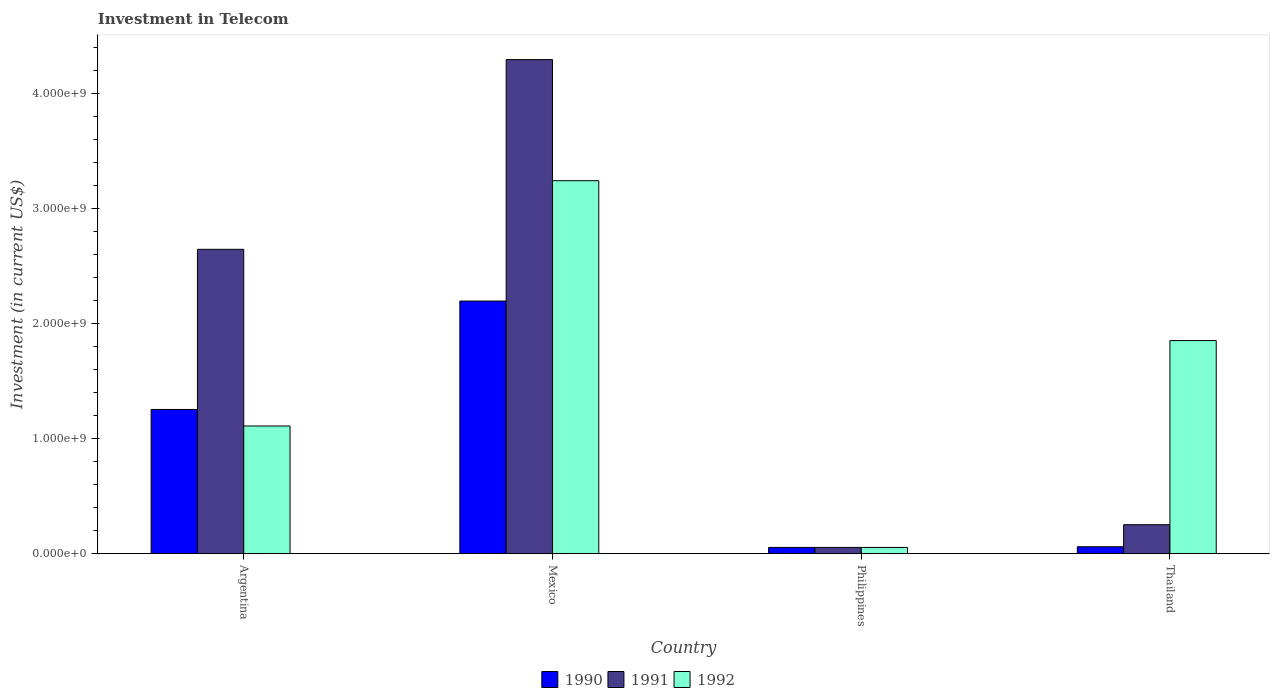How many different coloured bars are there?
Make the answer very short. 3. Are the number of bars per tick equal to the number of legend labels?
Offer a very short reply. Yes. How many bars are there on the 2nd tick from the left?
Offer a very short reply. 3. What is the label of the 1st group of bars from the left?
Your response must be concise. Argentina. What is the amount invested in telecom in 1992 in Thailand?
Make the answer very short. 1.85e+09. Across all countries, what is the maximum amount invested in telecom in 1991?
Your answer should be compact. 4.30e+09. Across all countries, what is the minimum amount invested in telecom in 1991?
Provide a short and direct response. 5.42e+07. In which country was the amount invested in telecom in 1991 minimum?
Your response must be concise. Philippines. What is the total amount invested in telecom in 1992 in the graph?
Make the answer very short. 6.26e+09. What is the difference between the amount invested in telecom in 1992 in Argentina and that in Thailand?
Provide a short and direct response. -7.43e+08. What is the difference between the amount invested in telecom in 1991 in Thailand and the amount invested in telecom in 1990 in Philippines?
Your response must be concise. 1.98e+08. What is the average amount invested in telecom in 1990 per country?
Keep it short and to the point. 8.92e+08. What is the ratio of the amount invested in telecom in 1992 in Argentina to that in Philippines?
Your answer should be very brief. 20.5. Is the amount invested in telecom in 1992 in Philippines less than that in Thailand?
Ensure brevity in your answer.  Yes. What is the difference between the highest and the second highest amount invested in telecom in 1990?
Provide a short and direct response. 2.14e+09. What is the difference between the highest and the lowest amount invested in telecom in 1991?
Your response must be concise. 4.24e+09. Is it the case that in every country, the sum of the amount invested in telecom in 1992 and amount invested in telecom in 1990 is greater than the amount invested in telecom in 1991?
Ensure brevity in your answer.  No. Are the values on the major ticks of Y-axis written in scientific E-notation?
Provide a succinct answer. Yes. Does the graph contain any zero values?
Provide a succinct answer. No. How are the legend labels stacked?
Ensure brevity in your answer.  Horizontal. What is the title of the graph?
Provide a succinct answer. Investment in Telecom. Does "1991" appear as one of the legend labels in the graph?
Ensure brevity in your answer.  Yes. What is the label or title of the X-axis?
Offer a terse response. Country. What is the label or title of the Y-axis?
Provide a succinct answer. Investment (in current US$). What is the Investment (in current US$) of 1990 in Argentina?
Your response must be concise. 1.25e+09. What is the Investment (in current US$) of 1991 in Argentina?
Offer a very short reply. 2.65e+09. What is the Investment (in current US$) in 1992 in Argentina?
Your response must be concise. 1.11e+09. What is the Investment (in current US$) of 1990 in Mexico?
Give a very brief answer. 2.20e+09. What is the Investment (in current US$) in 1991 in Mexico?
Keep it short and to the point. 4.30e+09. What is the Investment (in current US$) in 1992 in Mexico?
Keep it short and to the point. 3.24e+09. What is the Investment (in current US$) in 1990 in Philippines?
Make the answer very short. 5.42e+07. What is the Investment (in current US$) in 1991 in Philippines?
Offer a very short reply. 5.42e+07. What is the Investment (in current US$) of 1992 in Philippines?
Give a very brief answer. 5.42e+07. What is the Investment (in current US$) of 1990 in Thailand?
Your answer should be very brief. 6.00e+07. What is the Investment (in current US$) in 1991 in Thailand?
Offer a very short reply. 2.52e+08. What is the Investment (in current US$) of 1992 in Thailand?
Offer a terse response. 1.85e+09. Across all countries, what is the maximum Investment (in current US$) of 1990?
Provide a succinct answer. 2.20e+09. Across all countries, what is the maximum Investment (in current US$) in 1991?
Provide a short and direct response. 4.30e+09. Across all countries, what is the maximum Investment (in current US$) of 1992?
Provide a short and direct response. 3.24e+09. Across all countries, what is the minimum Investment (in current US$) in 1990?
Your response must be concise. 5.42e+07. Across all countries, what is the minimum Investment (in current US$) in 1991?
Make the answer very short. 5.42e+07. Across all countries, what is the minimum Investment (in current US$) in 1992?
Provide a short and direct response. 5.42e+07. What is the total Investment (in current US$) of 1990 in the graph?
Give a very brief answer. 3.57e+09. What is the total Investment (in current US$) of 1991 in the graph?
Provide a short and direct response. 7.25e+09. What is the total Investment (in current US$) in 1992 in the graph?
Your answer should be very brief. 6.26e+09. What is the difference between the Investment (in current US$) in 1990 in Argentina and that in Mexico?
Offer a terse response. -9.43e+08. What is the difference between the Investment (in current US$) in 1991 in Argentina and that in Mexico?
Offer a very short reply. -1.65e+09. What is the difference between the Investment (in current US$) in 1992 in Argentina and that in Mexico?
Offer a very short reply. -2.13e+09. What is the difference between the Investment (in current US$) of 1990 in Argentina and that in Philippines?
Give a very brief answer. 1.20e+09. What is the difference between the Investment (in current US$) of 1991 in Argentina and that in Philippines?
Your answer should be very brief. 2.59e+09. What is the difference between the Investment (in current US$) of 1992 in Argentina and that in Philippines?
Your answer should be very brief. 1.06e+09. What is the difference between the Investment (in current US$) of 1990 in Argentina and that in Thailand?
Offer a terse response. 1.19e+09. What is the difference between the Investment (in current US$) in 1991 in Argentina and that in Thailand?
Offer a terse response. 2.40e+09. What is the difference between the Investment (in current US$) of 1992 in Argentina and that in Thailand?
Your answer should be compact. -7.43e+08. What is the difference between the Investment (in current US$) in 1990 in Mexico and that in Philippines?
Your answer should be compact. 2.14e+09. What is the difference between the Investment (in current US$) in 1991 in Mexico and that in Philippines?
Your answer should be compact. 4.24e+09. What is the difference between the Investment (in current US$) of 1992 in Mexico and that in Philippines?
Ensure brevity in your answer.  3.19e+09. What is the difference between the Investment (in current US$) in 1990 in Mexico and that in Thailand?
Your answer should be very brief. 2.14e+09. What is the difference between the Investment (in current US$) in 1991 in Mexico and that in Thailand?
Offer a terse response. 4.05e+09. What is the difference between the Investment (in current US$) in 1992 in Mexico and that in Thailand?
Make the answer very short. 1.39e+09. What is the difference between the Investment (in current US$) in 1990 in Philippines and that in Thailand?
Keep it short and to the point. -5.80e+06. What is the difference between the Investment (in current US$) of 1991 in Philippines and that in Thailand?
Provide a succinct answer. -1.98e+08. What is the difference between the Investment (in current US$) of 1992 in Philippines and that in Thailand?
Give a very brief answer. -1.80e+09. What is the difference between the Investment (in current US$) of 1990 in Argentina and the Investment (in current US$) of 1991 in Mexico?
Keep it short and to the point. -3.04e+09. What is the difference between the Investment (in current US$) of 1990 in Argentina and the Investment (in current US$) of 1992 in Mexico?
Your response must be concise. -1.99e+09. What is the difference between the Investment (in current US$) of 1991 in Argentina and the Investment (in current US$) of 1992 in Mexico?
Give a very brief answer. -5.97e+08. What is the difference between the Investment (in current US$) in 1990 in Argentina and the Investment (in current US$) in 1991 in Philippines?
Your response must be concise. 1.20e+09. What is the difference between the Investment (in current US$) in 1990 in Argentina and the Investment (in current US$) in 1992 in Philippines?
Your answer should be compact. 1.20e+09. What is the difference between the Investment (in current US$) in 1991 in Argentina and the Investment (in current US$) in 1992 in Philippines?
Ensure brevity in your answer.  2.59e+09. What is the difference between the Investment (in current US$) in 1990 in Argentina and the Investment (in current US$) in 1991 in Thailand?
Make the answer very short. 1.00e+09. What is the difference between the Investment (in current US$) of 1990 in Argentina and the Investment (in current US$) of 1992 in Thailand?
Your response must be concise. -5.99e+08. What is the difference between the Investment (in current US$) in 1991 in Argentina and the Investment (in current US$) in 1992 in Thailand?
Provide a succinct answer. 7.94e+08. What is the difference between the Investment (in current US$) in 1990 in Mexico and the Investment (in current US$) in 1991 in Philippines?
Ensure brevity in your answer.  2.14e+09. What is the difference between the Investment (in current US$) of 1990 in Mexico and the Investment (in current US$) of 1992 in Philippines?
Your response must be concise. 2.14e+09. What is the difference between the Investment (in current US$) of 1991 in Mexico and the Investment (in current US$) of 1992 in Philippines?
Ensure brevity in your answer.  4.24e+09. What is the difference between the Investment (in current US$) in 1990 in Mexico and the Investment (in current US$) in 1991 in Thailand?
Offer a terse response. 1.95e+09. What is the difference between the Investment (in current US$) of 1990 in Mexico and the Investment (in current US$) of 1992 in Thailand?
Give a very brief answer. 3.44e+08. What is the difference between the Investment (in current US$) of 1991 in Mexico and the Investment (in current US$) of 1992 in Thailand?
Provide a succinct answer. 2.44e+09. What is the difference between the Investment (in current US$) in 1990 in Philippines and the Investment (in current US$) in 1991 in Thailand?
Your response must be concise. -1.98e+08. What is the difference between the Investment (in current US$) of 1990 in Philippines and the Investment (in current US$) of 1992 in Thailand?
Provide a succinct answer. -1.80e+09. What is the difference between the Investment (in current US$) of 1991 in Philippines and the Investment (in current US$) of 1992 in Thailand?
Provide a succinct answer. -1.80e+09. What is the average Investment (in current US$) of 1990 per country?
Keep it short and to the point. 8.92e+08. What is the average Investment (in current US$) of 1991 per country?
Offer a very short reply. 1.81e+09. What is the average Investment (in current US$) in 1992 per country?
Your answer should be very brief. 1.57e+09. What is the difference between the Investment (in current US$) of 1990 and Investment (in current US$) of 1991 in Argentina?
Provide a succinct answer. -1.39e+09. What is the difference between the Investment (in current US$) in 1990 and Investment (in current US$) in 1992 in Argentina?
Give a very brief answer. 1.44e+08. What is the difference between the Investment (in current US$) of 1991 and Investment (in current US$) of 1992 in Argentina?
Make the answer very short. 1.54e+09. What is the difference between the Investment (in current US$) in 1990 and Investment (in current US$) in 1991 in Mexico?
Keep it short and to the point. -2.10e+09. What is the difference between the Investment (in current US$) of 1990 and Investment (in current US$) of 1992 in Mexico?
Your response must be concise. -1.05e+09. What is the difference between the Investment (in current US$) in 1991 and Investment (in current US$) in 1992 in Mexico?
Your response must be concise. 1.05e+09. What is the difference between the Investment (in current US$) in 1990 and Investment (in current US$) in 1991 in Philippines?
Make the answer very short. 0. What is the difference between the Investment (in current US$) of 1990 and Investment (in current US$) of 1991 in Thailand?
Keep it short and to the point. -1.92e+08. What is the difference between the Investment (in current US$) in 1990 and Investment (in current US$) in 1992 in Thailand?
Your answer should be very brief. -1.79e+09. What is the difference between the Investment (in current US$) of 1991 and Investment (in current US$) of 1992 in Thailand?
Offer a very short reply. -1.60e+09. What is the ratio of the Investment (in current US$) in 1990 in Argentina to that in Mexico?
Keep it short and to the point. 0.57. What is the ratio of the Investment (in current US$) in 1991 in Argentina to that in Mexico?
Your answer should be very brief. 0.62. What is the ratio of the Investment (in current US$) in 1992 in Argentina to that in Mexico?
Offer a terse response. 0.34. What is the ratio of the Investment (in current US$) in 1990 in Argentina to that in Philippines?
Your response must be concise. 23.15. What is the ratio of the Investment (in current US$) of 1991 in Argentina to that in Philippines?
Keep it short and to the point. 48.86. What is the ratio of the Investment (in current US$) of 1992 in Argentina to that in Philippines?
Your answer should be compact. 20.5. What is the ratio of the Investment (in current US$) in 1990 in Argentina to that in Thailand?
Make the answer very short. 20.91. What is the ratio of the Investment (in current US$) in 1991 in Argentina to that in Thailand?
Your response must be concise. 10.51. What is the ratio of the Investment (in current US$) of 1992 in Argentina to that in Thailand?
Keep it short and to the point. 0.6. What is the ratio of the Investment (in current US$) of 1990 in Mexico to that in Philippines?
Your answer should be compact. 40.55. What is the ratio of the Investment (in current US$) of 1991 in Mexico to that in Philippines?
Make the answer very short. 79.32. What is the ratio of the Investment (in current US$) of 1992 in Mexico to that in Philippines?
Your response must be concise. 59.87. What is the ratio of the Investment (in current US$) in 1990 in Mexico to that in Thailand?
Provide a succinct answer. 36.63. What is the ratio of the Investment (in current US$) in 1991 in Mexico to that in Thailand?
Offer a very short reply. 17.06. What is the ratio of the Investment (in current US$) of 1992 in Mexico to that in Thailand?
Your answer should be compact. 1.75. What is the ratio of the Investment (in current US$) in 1990 in Philippines to that in Thailand?
Your answer should be very brief. 0.9. What is the ratio of the Investment (in current US$) of 1991 in Philippines to that in Thailand?
Your answer should be compact. 0.22. What is the ratio of the Investment (in current US$) in 1992 in Philippines to that in Thailand?
Offer a very short reply. 0.03. What is the difference between the highest and the second highest Investment (in current US$) of 1990?
Ensure brevity in your answer.  9.43e+08. What is the difference between the highest and the second highest Investment (in current US$) in 1991?
Provide a short and direct response. 1.65e+09. What is the difference between the highest and the second highest Investment (in current US$) in 1992?
Offer a very short reply. 1.39e+09. What is the difference between the highest and the lowest Investment (in current US$) of 1990?
Make the answer very short. 2.14e+09. What is the difference between the highest and the lowest Investment (in current US$) in 1991?
Offer a very short reply. 4.24e+09. What is the difference between the highest and the lowest Investment (in current US$) of 1992?
Your response must be concise. 3.19e+09. 